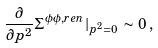<formula> <loc_0><loc_0><loc_500><loc_500>\frac { \partial } { \partial p ^ { 2 } } \Sigma ^ { \phi \phi , r e n } | _ { p ^ { 2 } = 0 } \, \sim \, 0 \, ,</formula> 